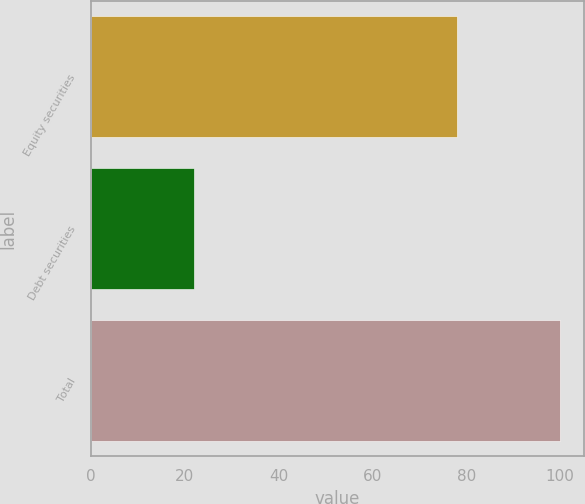<chart> <loc_0><loc_0><loc_500><loc_500><bar_chart><fcel>Equity securities<fcel>Debt securities<fcel>Total<nl><fcel>78<fcel>22<fcel>100<nl></chart> 